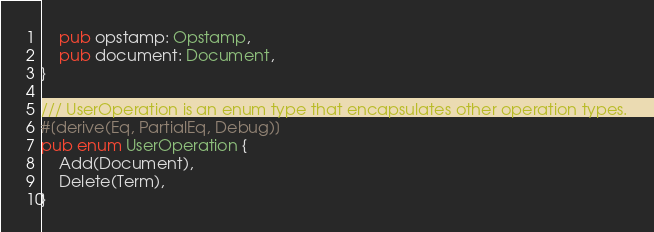<code> <loc_0><loc_0><loc_500><loc_500><_Rust_>    pub opstamp: Opstamp,
    pub document: Document,
}

/// UserOperation is an enum type that encapsulates other operation types.
#[derive(Eq, PartialEq, Debug)]
pub enum UserOperation {
    Add(Document),
    Delete(Term),
}
</code> 